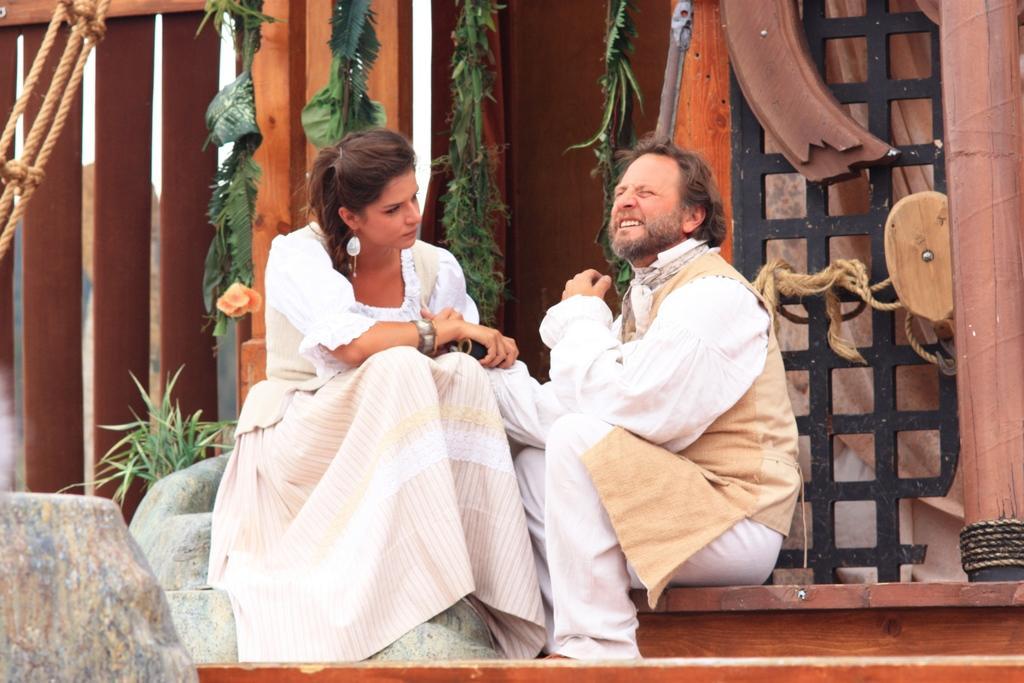How would you summarize this image in a sentence or two? In this image there are two personś sitting, one person is holding an object, there are plantś, there are ropes. 